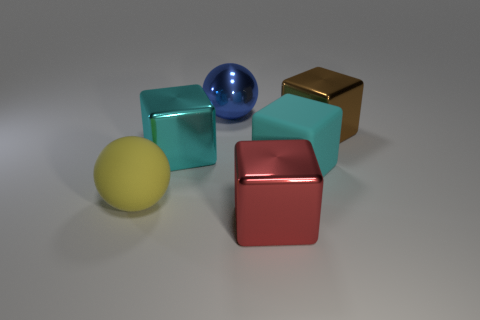Add 3 large brown balls. How many objects exist? 9 Subtract all cubes. How many objects are left? 2 Add 2 big brown shiny objects. How many big brown shiny objects are left? 3 Add 5 blue objects. How many blue objects exist? 6 Subtract 0 green cylinders. How many objects are left? 6 Subtract all big red metallic things. Subtract all big matte spheres. How many objects are left? 4 